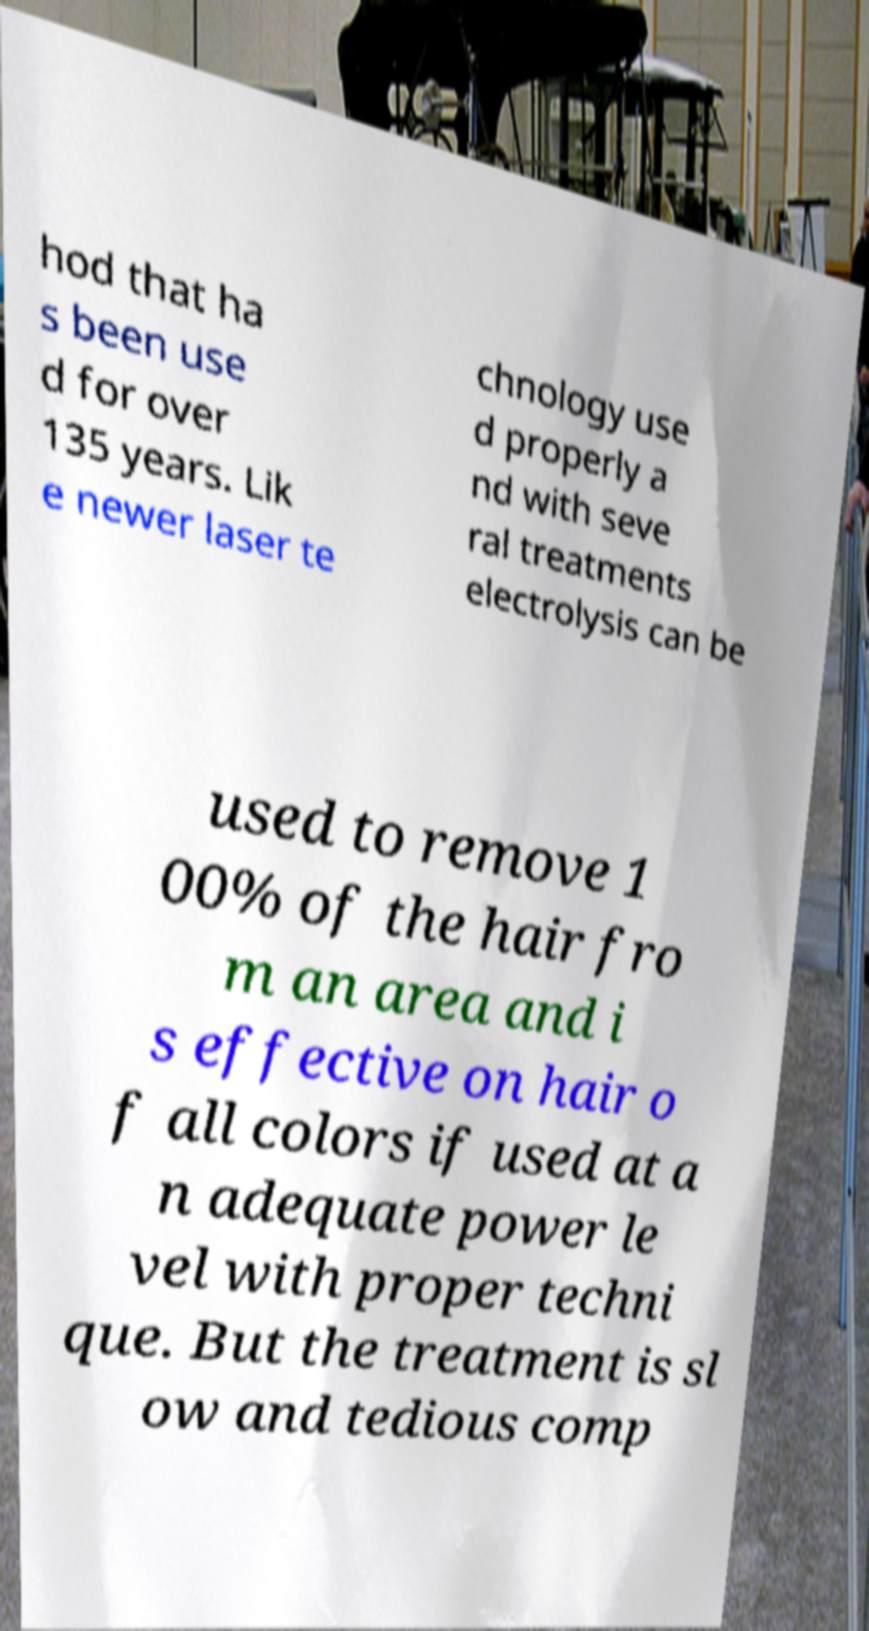Please identify and transcribe the text found in this image. hod that ha s been use d for over 135 years. Lik e newer laser te chnology use d properly a nd with seve ral treatments electrolysis can be used to remove 1 00% of the hair fro m an area and i s effective on hair o f all colors if used at a n adequate power le vel with proper techni que. But the treatment is sl ow and tedious comp 